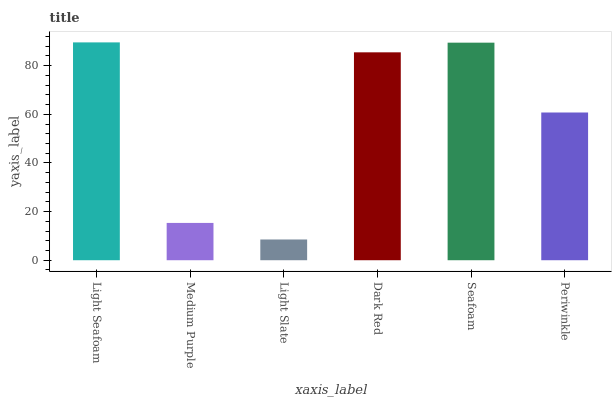Is Light Slate the minimum?
Answer yes or no. Yes. Is Light Seafoam the maximum?
Answer yes or no. Yes. Is Medium Purple the minimum?
Answer yes or no. No. Is Medium Purple the maximum?
Answer yes or no. No. Is Light Seafoam greater than Medium Purple?
Answer yes or no. Yes. Is Medium Purple less than Light Seafoam?
Answer yes or no. Yes. Is Medium Purple greater than Light Seafoam?
Answer yes or no. No. Is Light Seafoam less than Medium Purple?
Answer yes or no. No. Is Dark Red the high median?
Answer yes or no. Yes. Is Periwinkle the low median?
Answer yes or no. Yes. Is Light Slate the high median?
Answer yes or no. No. Is Light Seafoam the low median?
Answer yes or no. No. 